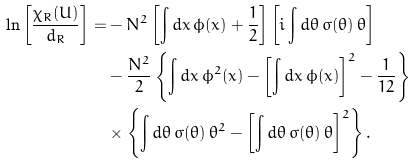<formula> <loc_0><loc_0><loc_500><loc_500>\ln \left [ \frac { \chi _ { R } ( U ) } { d _ { R } } \right ] = & - N ^ { 2 } \left [ \int d x \, \phi ( x ) + \frac { 1 } { 2 } \right ] \left [ i \int d \theta \, \sigma ( \theta ) \, \theta \right ] \\ & - \frac { N ^ { 2 } } { 2 } \left \{ \int d x \, \phi ^ { 2 } ( x ) - \left [ \int d x \, \phi ( x ) \right ] ^ { 2 } - \frac { 1 } { 1 2 } \right \} \\ & \times \left \{ \int d \theta \, \sigma ( \theta ) \, \theta ^ { 2 } - \left [ \int d \theta \, \sigma ( \theta ) \, \theta \right ] ^ { 2 } \right \} .</formula> 